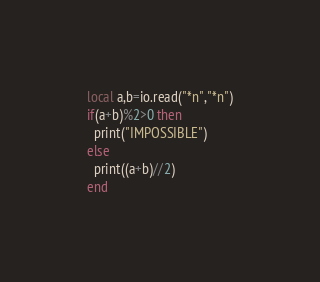Convert code to text. <code><loc_0><loc_0><loc_500><loc_500><_Lua_>local a,b=io.read("*n","*n")
if(a+b)%2>0 then
  print("IMPOSSIBLE")
else
  print((a+b)//2)
end</code> 